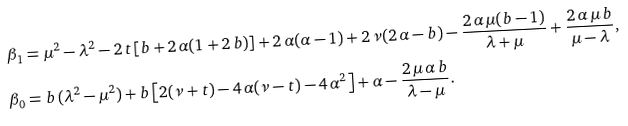<formula> <loc_0><loc_0><loc_500><loc_500>\beta _ { 1 } & = \mu ^ { 2 } - \lambda ^ { 2 } - 2 \, t \left [ b + 2 \, \alpha ( 1 + 2 \, b ) \right ] + 2 \, \alpha ( \alpha - 1 ) + 2 \, \nu ( 2 \, \alpha - b ) - \frac { 2 \, \alpha \, \mu ( b - 1 ) } { \lambda + \mu } + \frac { 2 \, \alpha \, \mu \, b } { \mu - \lambda } , \\ \beta _ { 0 } & = b \, ( \lambda ^ { 2 } - \mu ^ { 2 } ) + b \left [ 2 ( \nu + t ) - 4 \, \alpha ( \nu - t ) - 4 \, \alpha ^ { 2 } \right ] + \alpha - \frac { 2 \, \mu \, \alpha \, b } { \lambda - \mu } .</formula> 